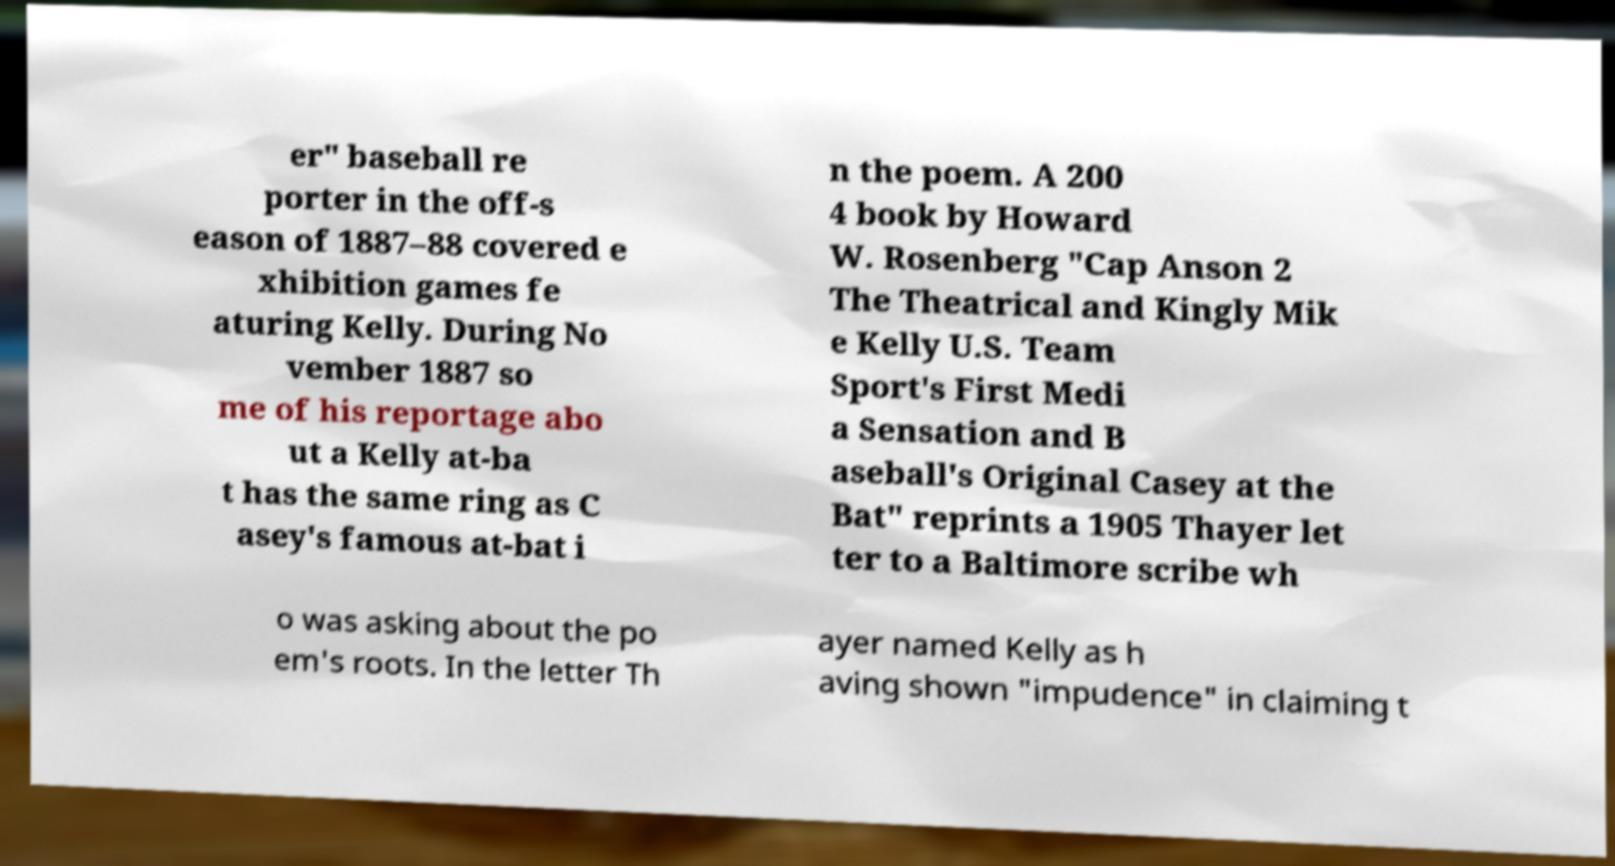Please read and relay the text visible in this image. What does it say? er" baseball re porter in the off-s eason of 1887–88 covered e xhibition games fe aturing Kelly. During No vember 1887 so me of his reportage abo ut a Kelly at-ba t has the same ring as C asey's famous at-bat i n the poem. A 200 4 book by Howard W. Rosenberg "Cap Anson 2 The Theatrical and Kingly Mik e Kelly U.S. Team Sport's First Medi a Sensation and B aseball's Original Casey at the Bat" reprints a 1905 Thayer let ter to a Baltimore scribe wh o was asking about the po em's roots. In the letter Th ayer named Kelly as h aving shown "impudence" in claiming t 